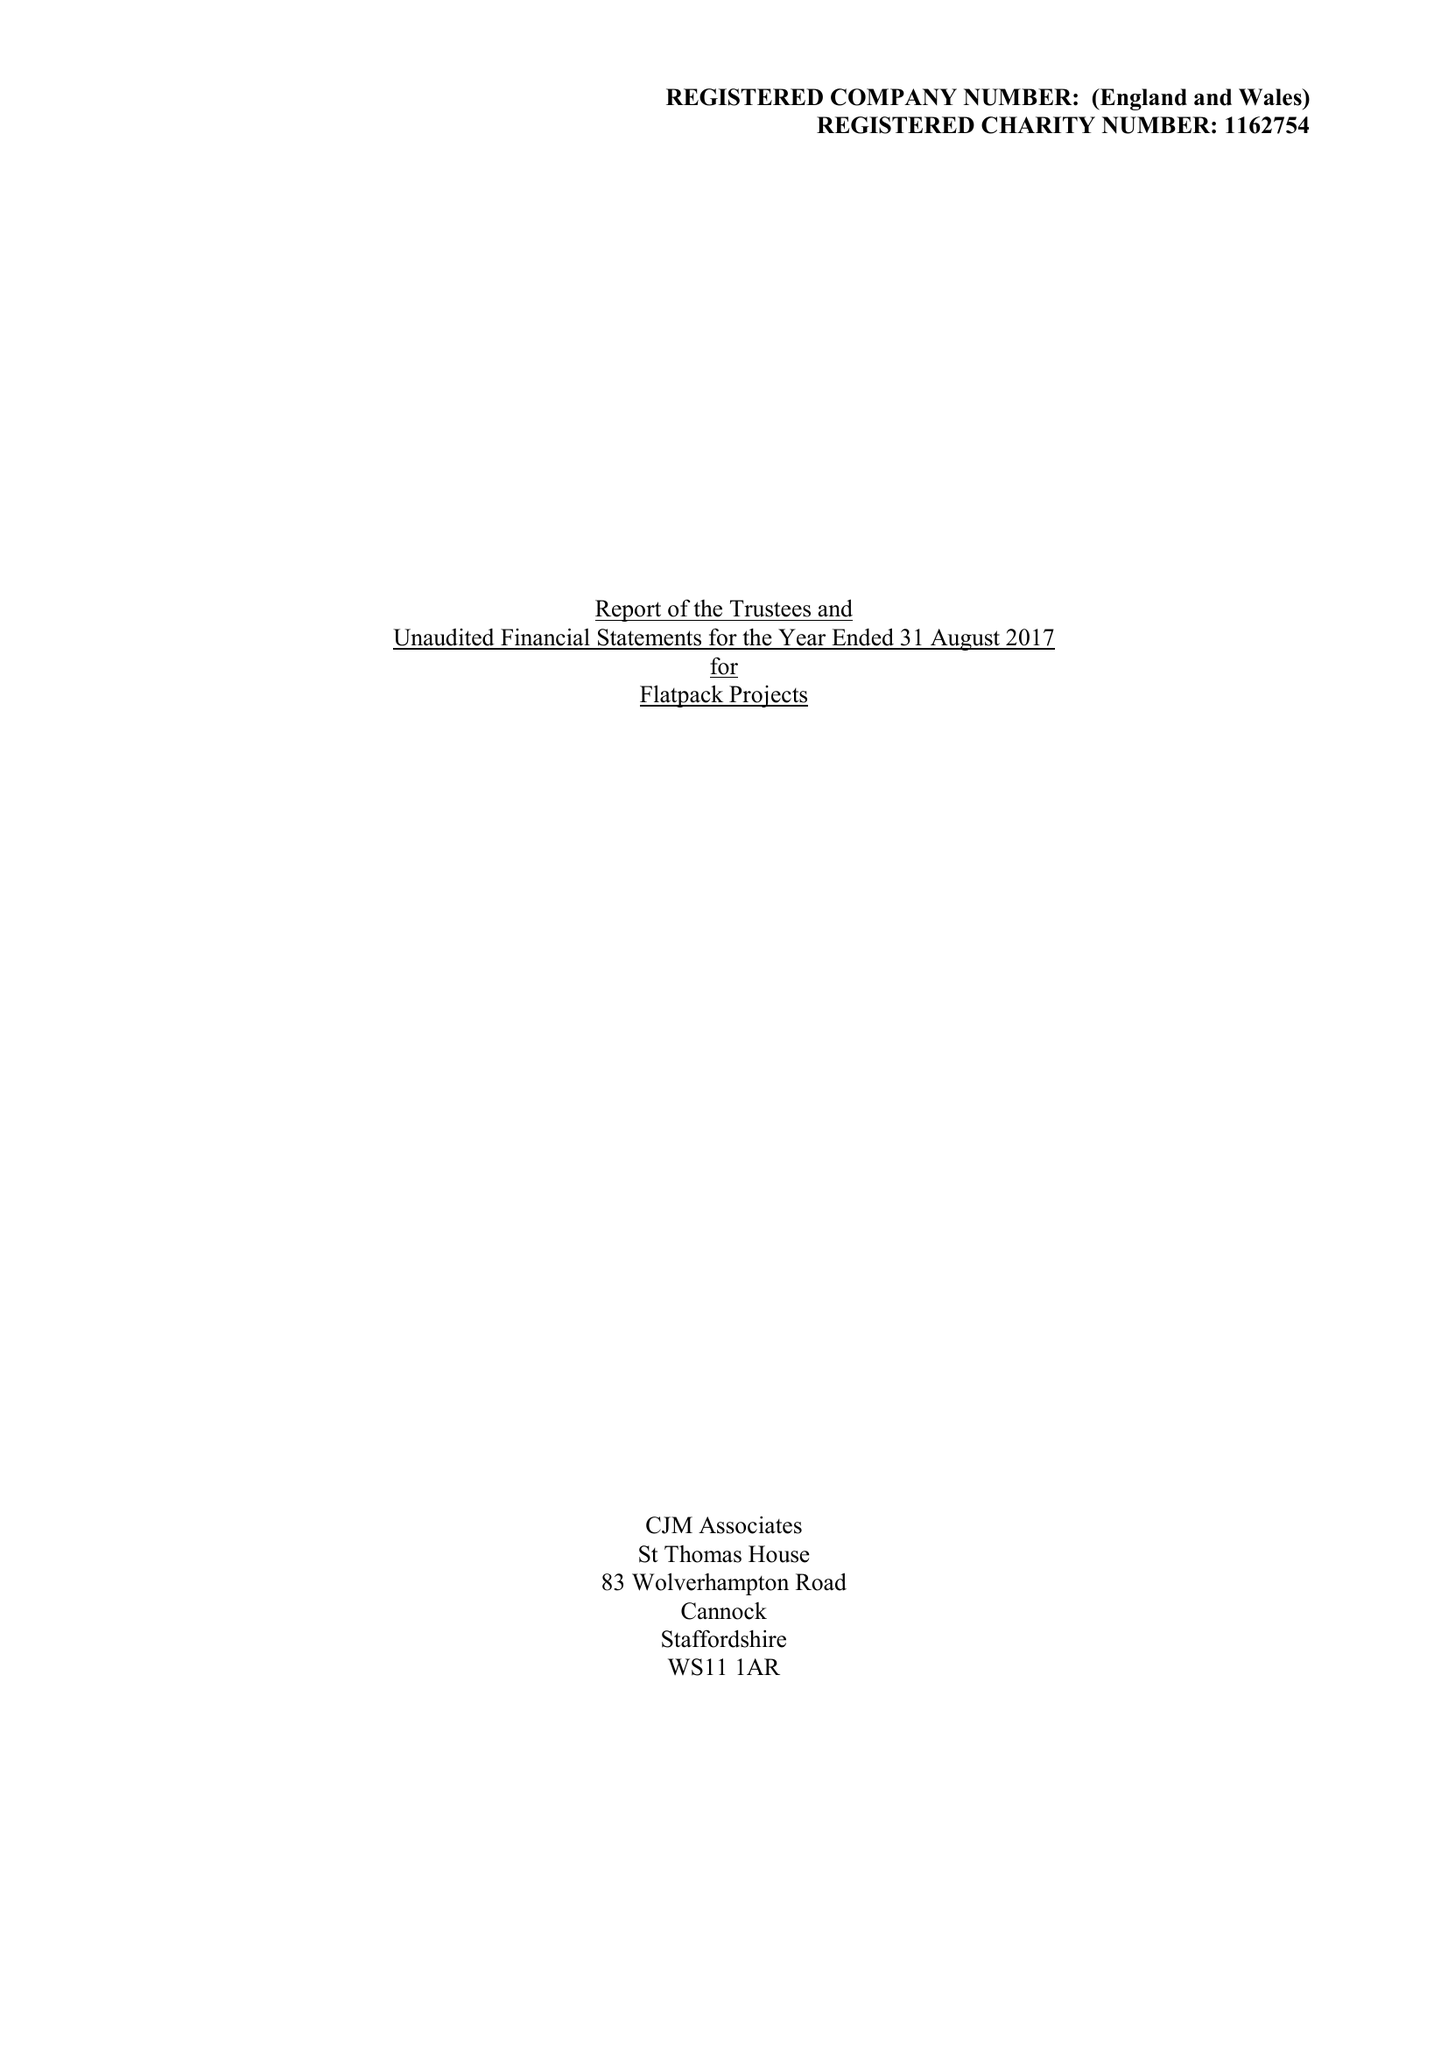What is the value for the address__postcode?
Answer the question using a single word or phrase. B9 4AA 